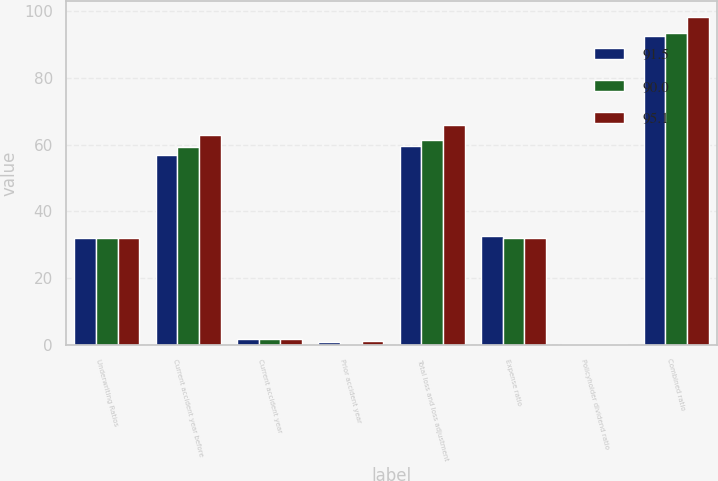Convert chart to OTSL. <chart><loc_0><loc_0><loc_500><loc_500><stacked_bar_chart><ecel><fcel>Underwriting Ratios<fcel>Current accident year before<fcel>Current accident year<fcel>Prior accident year<fcel>Total loss and loss adjustment<fcel>Expense ratio<fcel>Policyholder dividend ratio<fcel>Combined ratio<nl><fcel>91.5<fcel>32<fcel>57<fcel>1.9<fcel>0.8<fcel>59.7<fcel>32.7<fcel>0.3<fcel>92.6<nl><fcel>90<fcel>32<fcel>59.4<fcel>1.7<fcel>0.2<fcel>61.3<fcel>31.9<fcel>0.2<fcel>93.4<nl><fcel>95.1<fcel>32<fcel>62.8<fcel>1.7<fcel>1.3<fcel>65.9<fcel>32<fcel>0.3<fcel>98.1<nl></chart> 